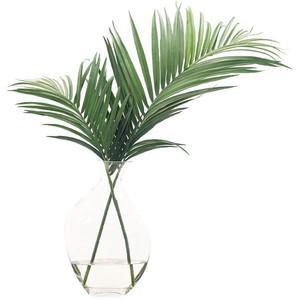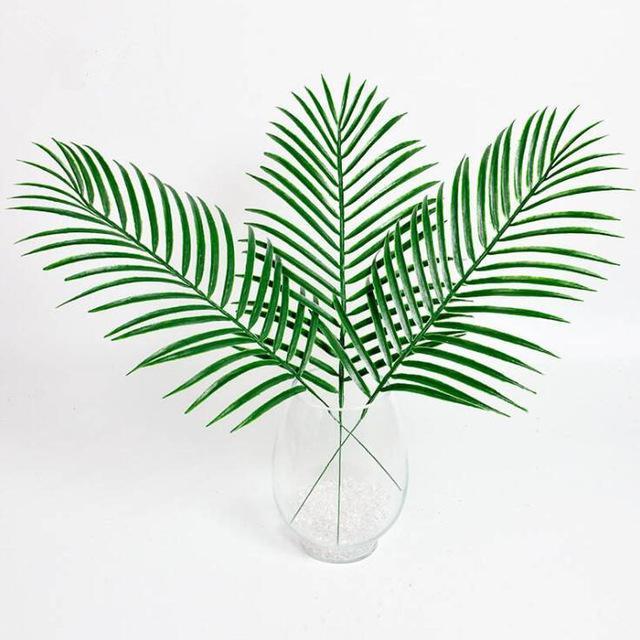The first image is the image on the left, the second image is the image on the right. Evaluate the accuracy of this statement regarding the images: "The right image includes a vase holding green fronds that don't have spiky grass-like leaves.". Is it true? Answer yes or no. No. 